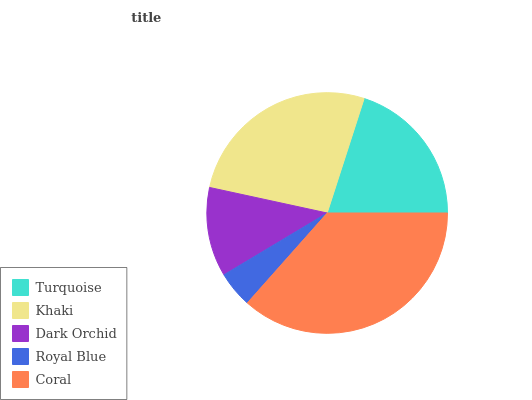Is Royal Blue the minimum?
Answer yes or no. Yes. Is Coral the maximum?
Answer yes or no. Yes. Is Khaki the minimum?
Answer yes or no. No. Is Khaki the maximum?
Answer yes or no. No. Is Khaki greater than Turquoise?
Answer yes or no. Yes. Is Turquoise less than Khaki?
Answer yes or no. Yes. Is Turquoise greater than Khaki?
Answer yes or no. No. Is Khaki less than Turquoise?
Answer yes or no. No. Is Turquoise the high median?
Answer yes or no. Yes. Is Turquoise the low median?
Answer yes or no. Yes. Is Coral the high median?
Answer yes or no. No. Is Royal Blue the low median?
Answer yes or no. No. 